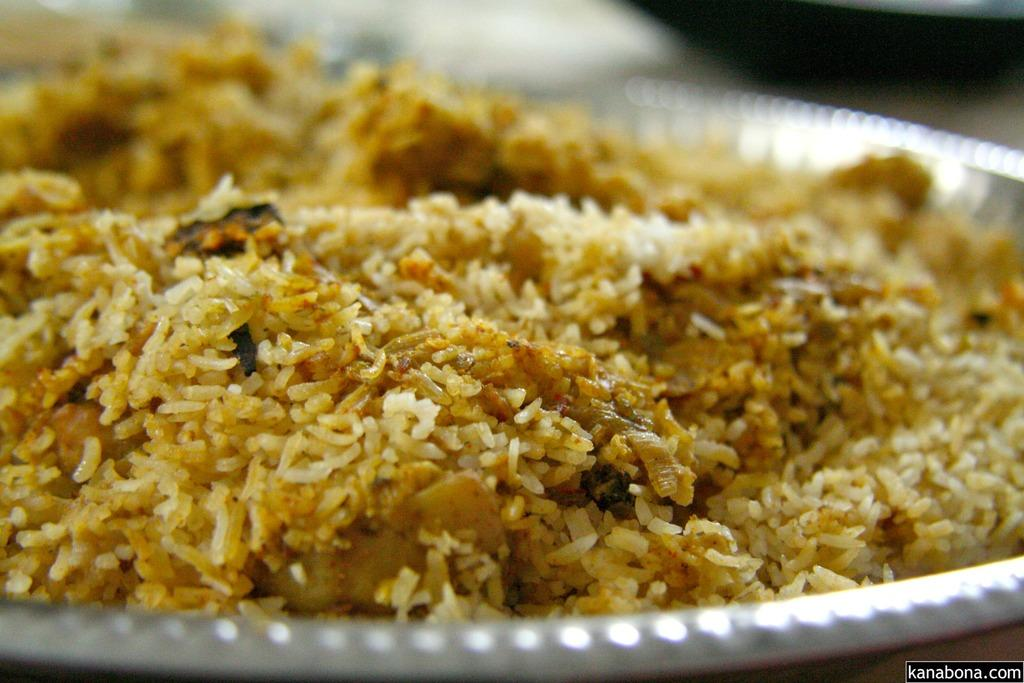What type of food is visible in the image? The food in the image is in brown color. What color is the plate that holds the food? The plate is in white color. Who is the creator of the food in the image? The image does not provide information about the creator of the food. 